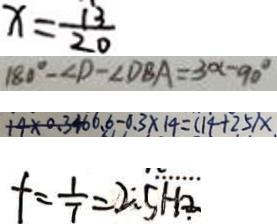<formula> <loc_0><loc_0><loc_500><loc_500>x = \frac { 1 3 } { 2 0 } 
 1 8 0 ^ { \circ } - \angle D - \angle D B A = 3 0 ^ { \circ } - 9 0 ^ { \circ } 
 + 4 \times 0 . 3 4 6 6 . 6 - 0 . 3 \times 1 4 = ( 1 4 + 2 5 ) x . 
 f = \frac { 1 } { 7 } = 2 . 5 H 2 _ { \cdot }</formula> 